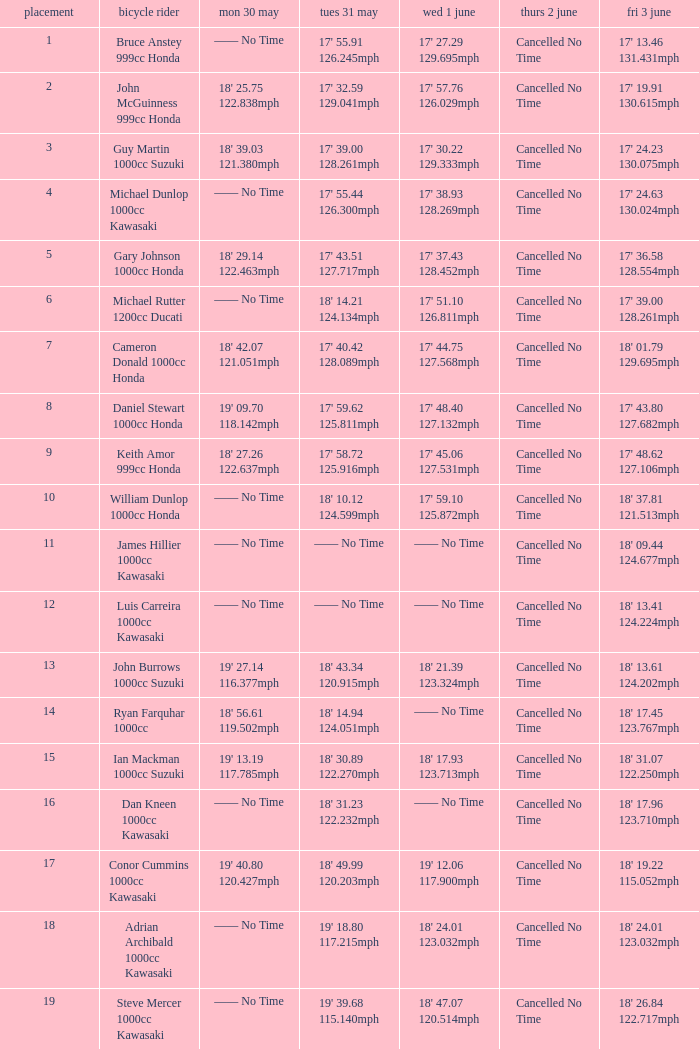What is the Thurs 2 June time for the rider with a Fri 3 June time of 17' 36.58 128.554mph? Cancelled No Time. 